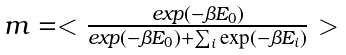<formula> <loc_0><loc_0><loc_500><loc_500>\begin{array} { l } m = < \frac { e x p ( - \beta E _ { 0 } ) } { e x p ( - \beta E _ { 0 } ) + \sum _ { i } \exp ( - \beta E _ { i } ) } > \end{array}</formula> 